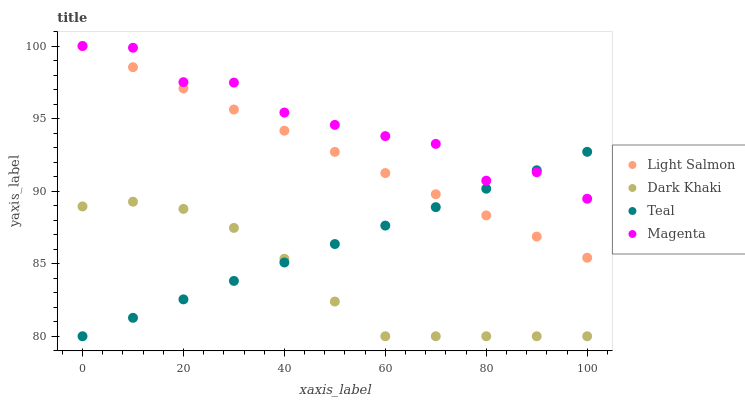Does Dark Khaki have the minimum area under the curve?
Answer yes or no. Yes. Does Magenta have the maximum area under the curve?
Answer yes or no. Yes. Does Light Salmon have the minimum area under the curve?
Answer yes or no. No. Does Light Salmon have the maximum area under the curve?
Answer yes or no. No. Is Light Salmon the smoothest?
Answer yes or no. Yes. Is Magenta the roughest?
Answer yes or no. Yes. Is Magenta the smoothest?
Answer yes or no. No. Is Light Salmon the roughest?
Answer yes or no. No. Does Dark Khaki have the lowest value?
Answer yes or no. Yes. Does Light Salmon have the lowest value?
Answer yes or no. No. Does Magenta have the highest value?
Answer yes or no. Yes. Does Teal have the highest value?
Answer yes or no. No. Is Dark Khaki less than Light Salmon?
Answer yes or no. Yes. Is Magenta greater than Dark Khaki?
Answer yes or no. Yes. Does Teal intersect Light Salmon?
Answer yes or no. Yes. Is Teal less than Light Salmon?
Answer yes or no. No. Is Teal greater than Light Salmon?
Answer yes or no. No. Does Dark Khaki intersect Light Salmon?
Answer yes or no. No. 